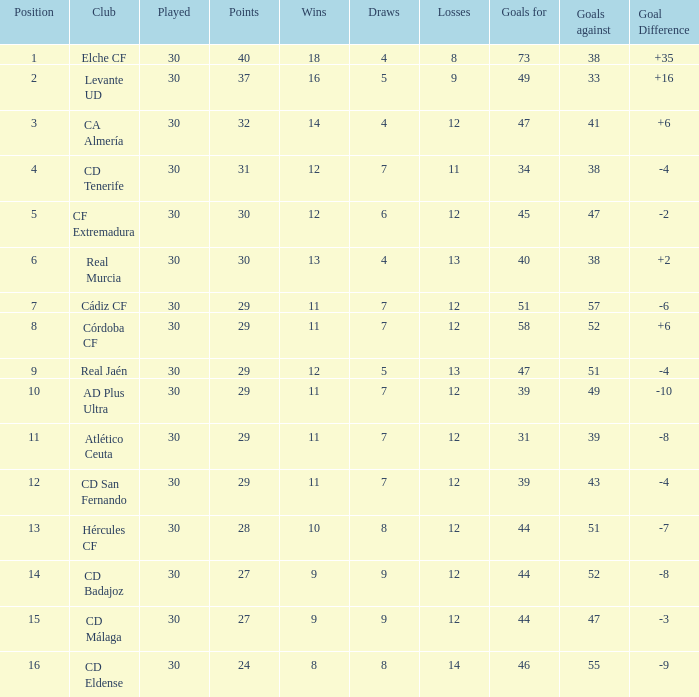What is the highest amount of goals with more than 51 goals against and less than 30 played? None. 